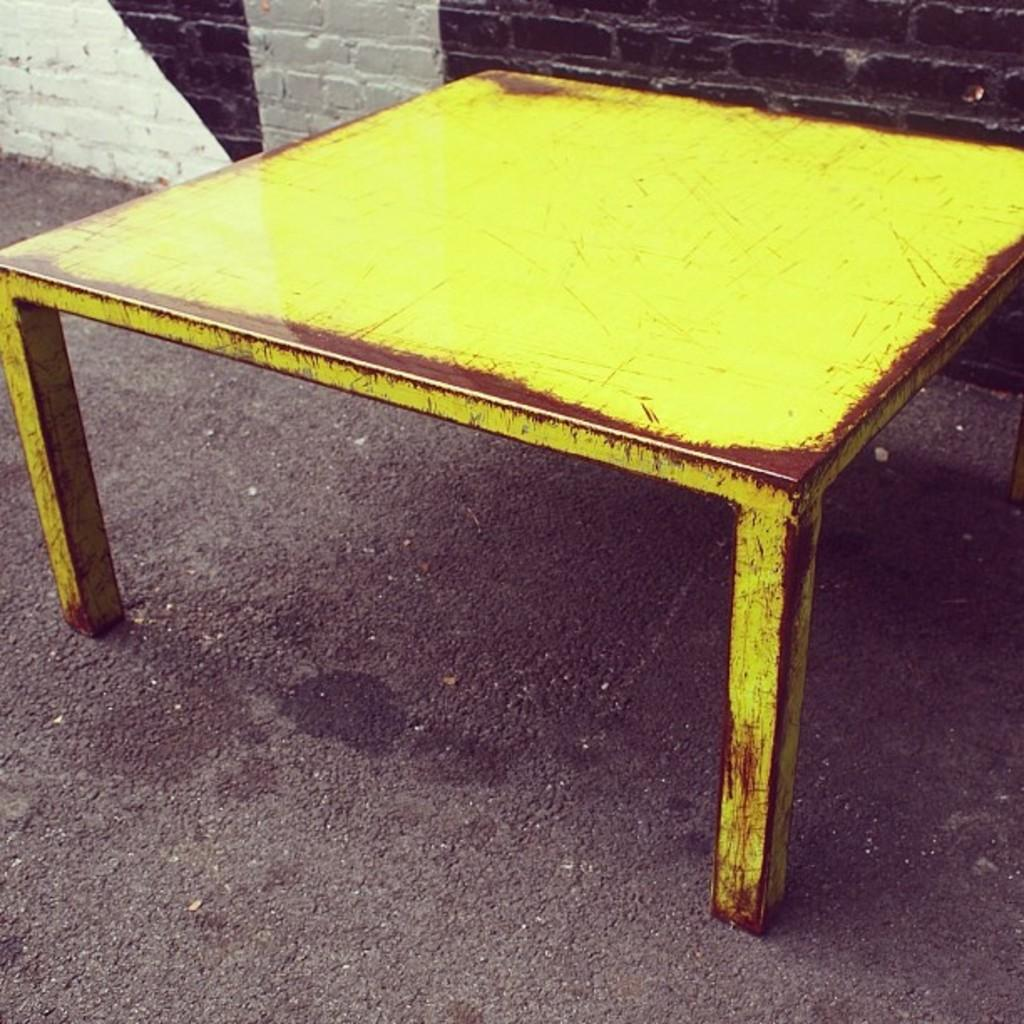What is the color of the object on the ground in the image? The object on the ground in the image is yellow and brown. What can be seen in the background of the image? There is a wall visible in the background of the image. How does the object on the ground in the image help with sorting tasks? The object on the ground in the image does not have any apparent function related to sorting tasks. 